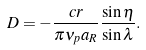<formula> <loc_0><loc_0><loc_500><loc_500>D = - \frac { c r } { \pi \nu _ { p } a _ { R } } \frac { \sin \eta } { \sin \lambda } .</formula> 